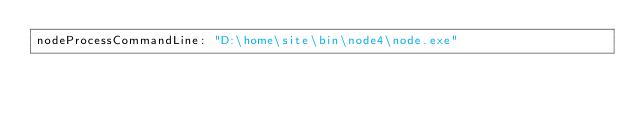Convert code to text. <code><loc_0><loc_0><loc_500><loc_500><_YAML_>nodeProcessCommandLine: "D:\home\site\bin\node4\node.exe"</code> 